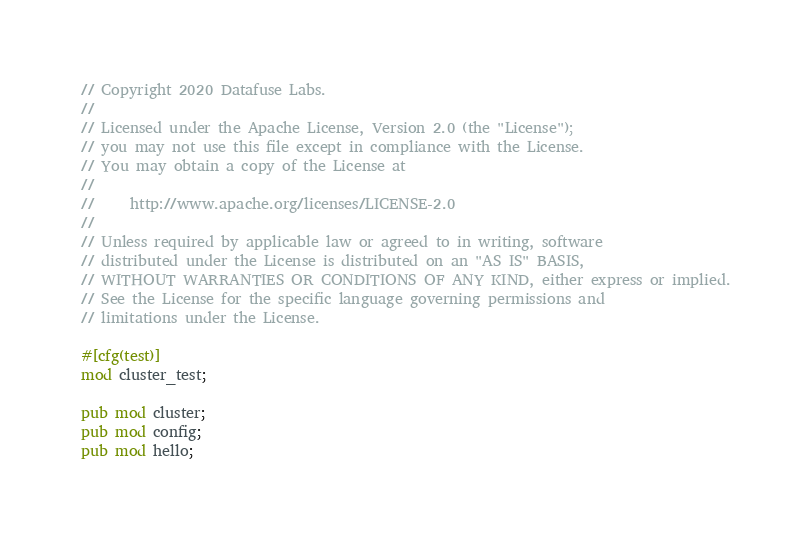<code> <loc_0><loc_0><loc_500><loc_500><_Rust_>// Copyright 2020 Datafuse Labs.
//
// Licensed under the Apache License, Version 2.0 (the "License");
// you may not use this file except in compliance with the License.
// You may obtain a copy of the License at
//
//     http://www.apache.org/licenses/LICENSE-2.0
//
// Unless required by applicable law or agreed to in writing, software
// distributed under the License is distributed on an "AS IS" BASIS,
// WITHOUT WARRANTIES OR CONDITIONS OF ANY KIND, either express or implied.
// See the License for the specific language governing permissions and
// limitations under the License.

#[cfg(test)]
mod cluster_test;

pub mod cluster;
pub mod config;
pub mod hello;
</code> 